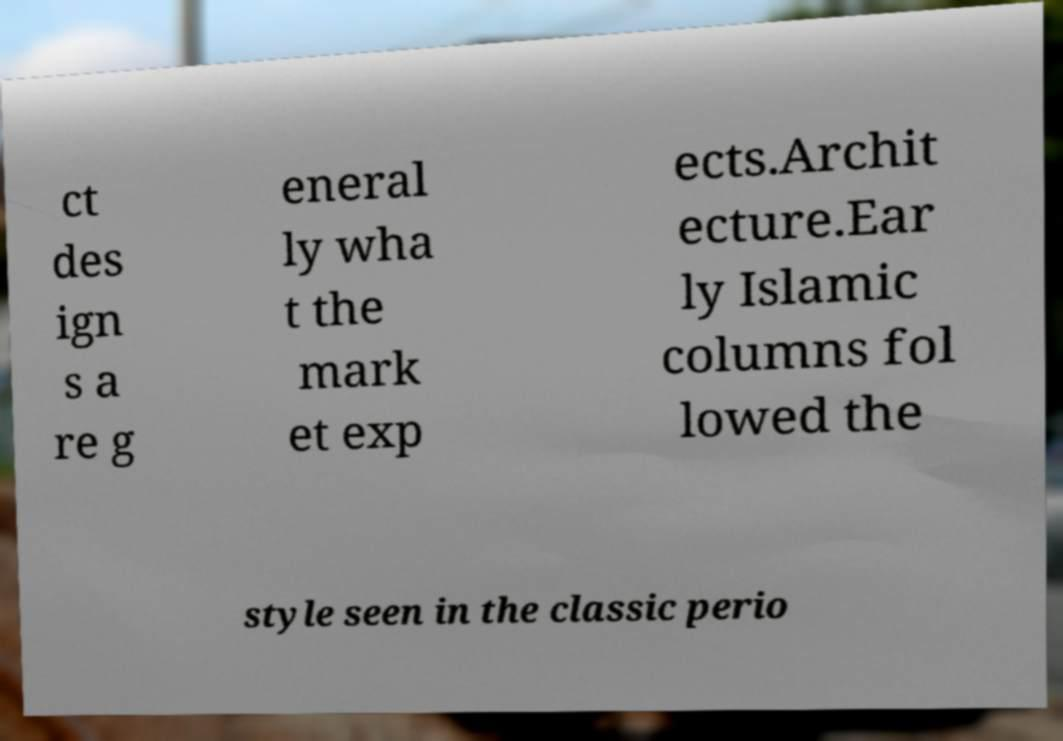What messages or text are displayed in this image? I need them in a readable, typed format. ct des ign s a re g eneral ly wha t the mark et exp ects.Archit ecture.Ear ly Islamic columns fol lowed the style seen in the classic perio 